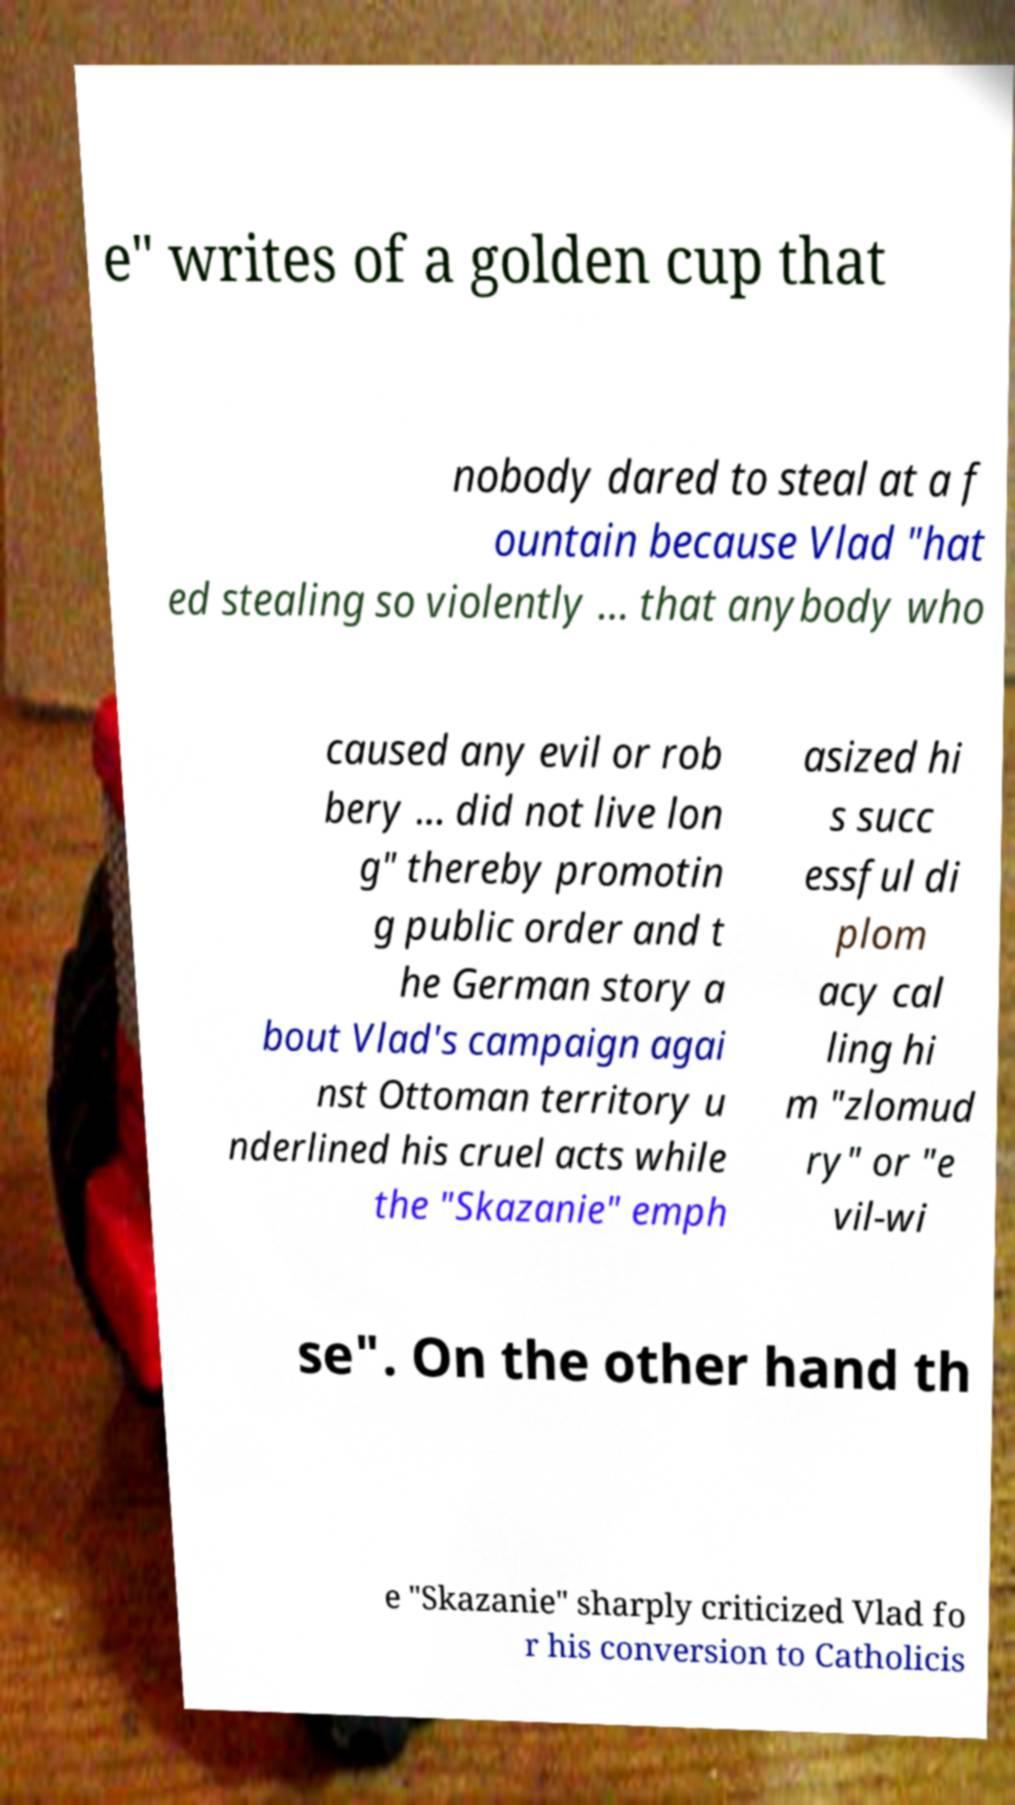Please read and relay the text visible in this image. What does it say? e" writes of a golden cup that nobody dared to steal at a f ountain because Vlad "hat ed stealing so violently ... that anybody who caused any evil or rob bery ... did not live lon g" thereby promotin g public order and t he German story a bout Vlad's campaign agai nst Ottoman territory u nderlined his cruel acts while the "Skazanie" emph asized hi s succ essful di plom acy cal ling hi m "zlomud ry" or "e vil-wi se". On the other hand th e "Skazanie" sharply criticized Vlad fo r his conversion to Catholicis 